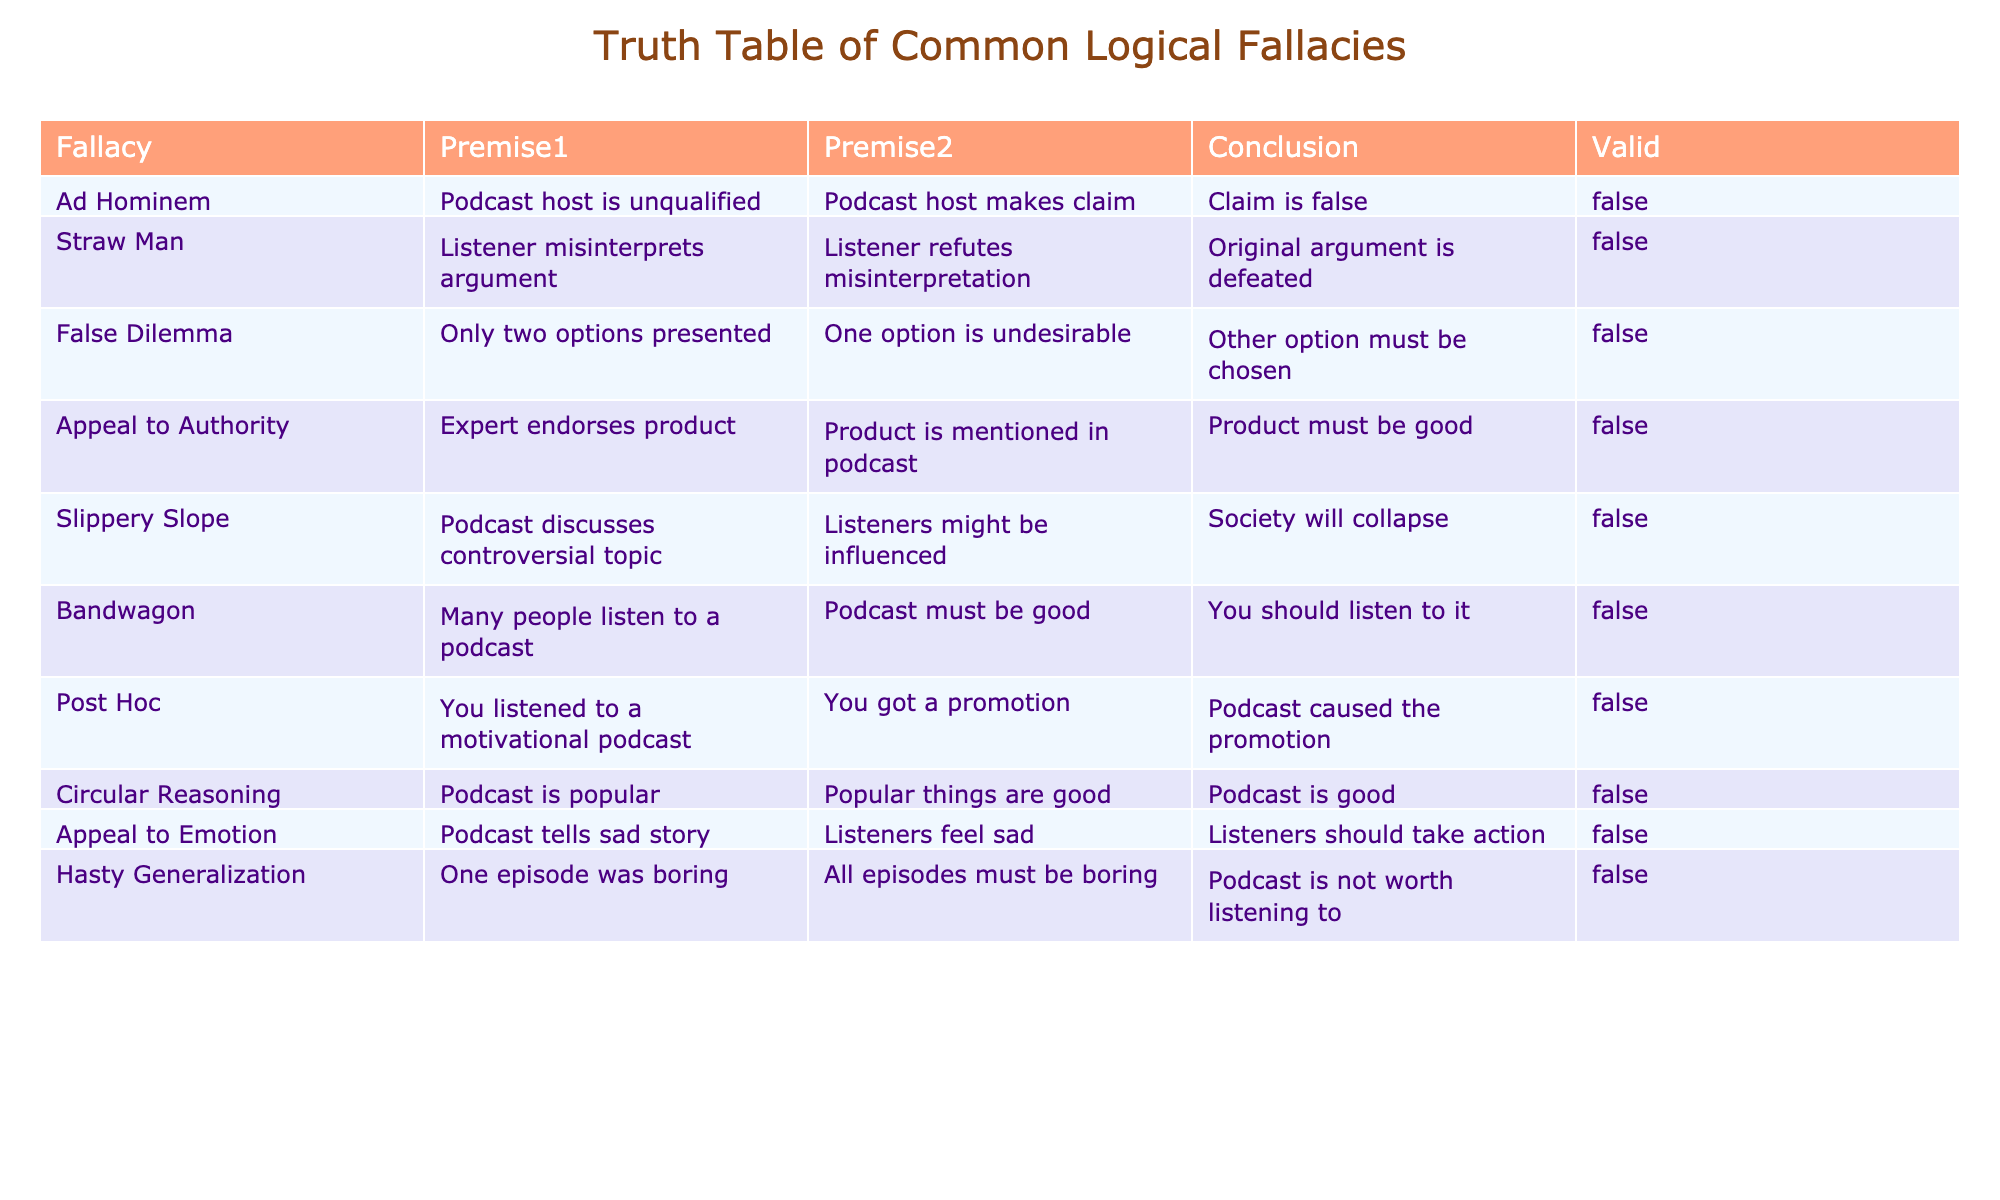What type of fallacy is characterized by attacking the person rather than the argument? The table lists various fallacies, and under the "Fallacy" column, "Ad Hominem" specifically refers to attacking the person making the argument instead of addressing the argument itself.
Answer: Ad Hominem How many fallacies listed in the table have a valid outcome of FALSE? All the fallacies in the table are marked with "FALSE" under the "Valid" column. Therefore, there are 10 fallacies in total, all invalid.
Answer: 10 Is the claim "Podcast is good" a conclusion reached through Circular Reasoning? The conclusion "Podcast is good" corresponds to the "Circular Reasoning" fallacy in the table, where "Podcast is popular" leads back to determining the podcast's quality in a loop without independent evidence.
Answer: Yes Which two fallacies both imply the idea of making conclusions based on insufficient evidence? "Hasty Generalization" and "Post Hoc" both deal with insufficient evidence leading to conclusions. "Hasty Generalization" makes a broad conclusion from a single episode, while "Post Hoc" blames a promotion solely on listening to a motivational podcast without solid evidence.
Answer: Hasty Generalization and Post Hoc If we consider "Bandwagon" and "False Dilemma," which one suggests that one must choose between only two options? The "False Dilemma" fallacy presents only two options—if one is deemed undesirable, the other must be chosen. In contrast, "Bandwagon" appeals to popularity without any conditionality on the options.
Answer: False Dilemma 